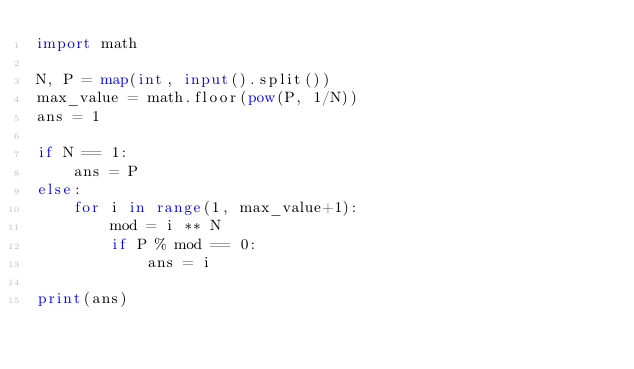Convert code to text. <code><loc_0><loc_0><loc_500><loc_500><_Python_>import math

N, P = map(int, input().split())
max_value = math.floor(pow(P, 1/N))
ans = 1

if N == 1:
    ans = P
else:
    for i in range(1, max_value+1):
        mod = i ** N
        if P % mod == 0:
            ans = i

print(ans)
</code> 